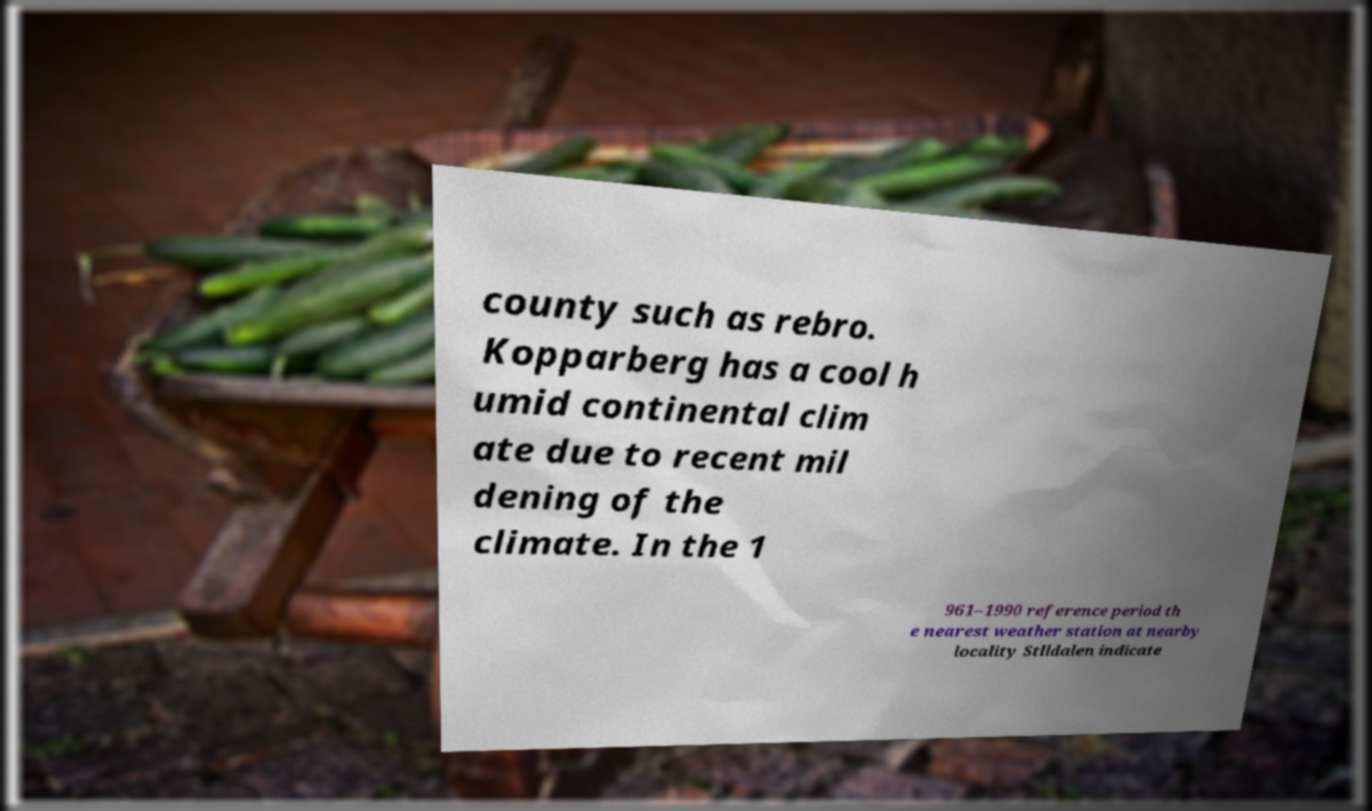Please identify and transcribe the text found in this image. county such as rebro. Kopparberg has a cool h umid continental clim ate due to recent mil dening of the climate. In the 1 961–1990 reference period th e nearest weather station at nearby locality Stlldalen indicate 